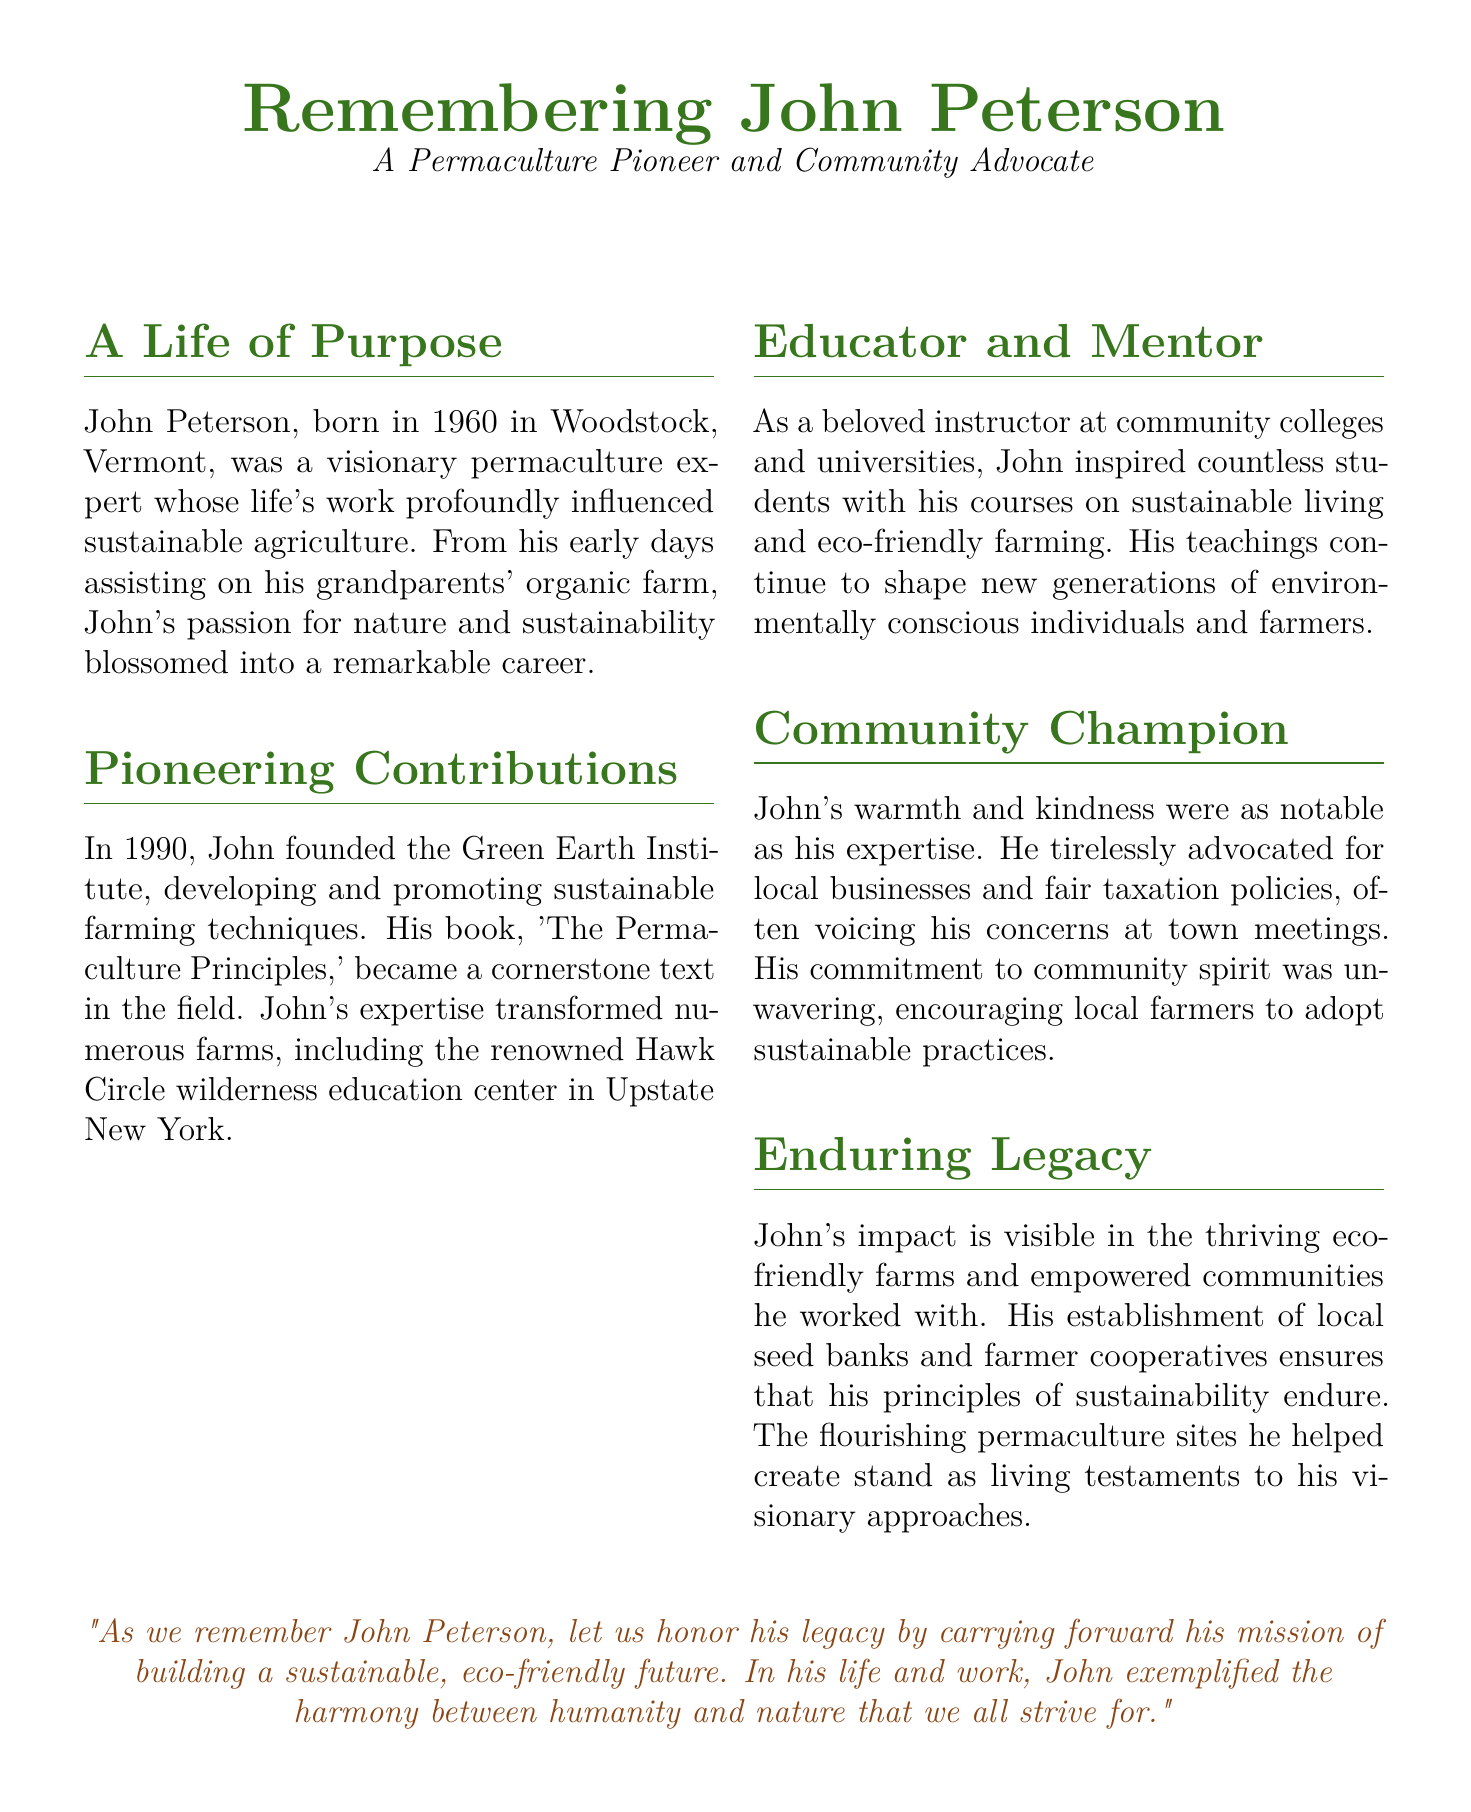What is the name of the permaculture expert? The document states that John Peterson was the permaculture expert being remembered.
Answer: John Peterson What year was John Peterson born? The document mentions John was born in 1960.
Answer: 1960 What was the name of the institute founded by John? The document specifies that John founded the Green Earth Institute.
Answer: Green Earth Institute What is the title of John's book? According to the document, John's book is titled 'The Permaculture Principles.'
Answer: The Permaculture Principles In what year did John found the Green Earth Institute? The document states that John founded the institute in 1990.
Answer: 1990 Which type of farming practices did John advocate for? The document mentions that John advocated for sustainable farming practices.
Answer: Sustainable What did John establish to ensure sustainability? The document notes that John established local seed banks and farmer cooperatives.
Answer: Local seed banks and farmer cooperatives What type of educator was John described as? The document describes John as a beloved instructor.
Answer: Beloved instructor What sentiment does the closing quote express about John's legacy? The closing quote emphasizes the importance of carrying forward John's mission of sustainability.
Answer: Building a sustainable, eco-friendly future 